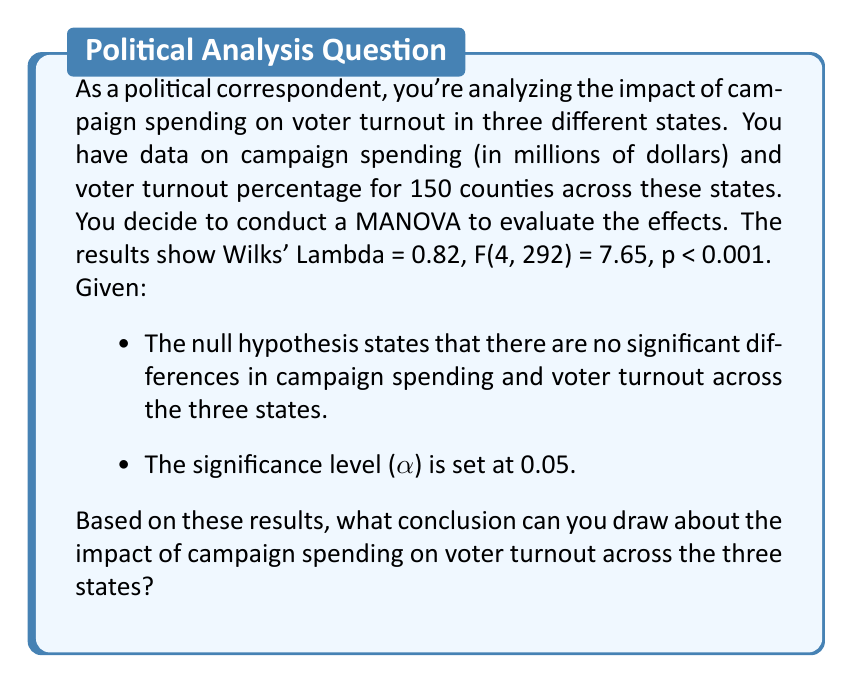Can you answer this question? To interpret the MANOVA results and draw a conclusion, we need to follow these steps:

1. Understand the given information:
   - We have two dependent variables: campaign spending and voter turnout
   - We have one independent variable: state (with three levels)
   - Wilks' Lambda = 0.82
   - F(4, 292) = 7.65
   - p < 0.001
   - α = 0.05

2. Interpret Wilks' Lambda:
   - Wilks' Lambda ranges from 0 to 1
   - Smaller values indicate greater differences between groups
   - Our value of 0.82 suggests some differences between the states

3. Evaluate the F-statistic and p-value:
   - F(4, 292) = 7.65 represents the F-statistic with 4 numerator degrees of freedom and 292 denominator degrees of freedom
   - p < 0.001 is the probability of obtaining this F-statistic by chance

4. Compare p-value to significance level:
   - p < 0.001 is less than α = 0.05

5. Make a decision about the null hypothesis:
   - Since p < α, we reject the null hypothesis

6. Draw a conclusion:
   - Rejecting the null hypothesis means there are significant differences in campaign spending and voter turnout across the three states
   - This suggests that campaign spending does have an impact on voter turnout, and this impact varies by state

7. Consider the implications for political reporting:
   - As a political correspondent, you can report that campaign spending strategies may need to be tailored to each state, as their effectiveness in influencing voter turnout appears to differ across states
Answer: Reject the null hypothesis; campaign spending significantly impacts voter turnout, with effects varying across states (p < 0.001). 